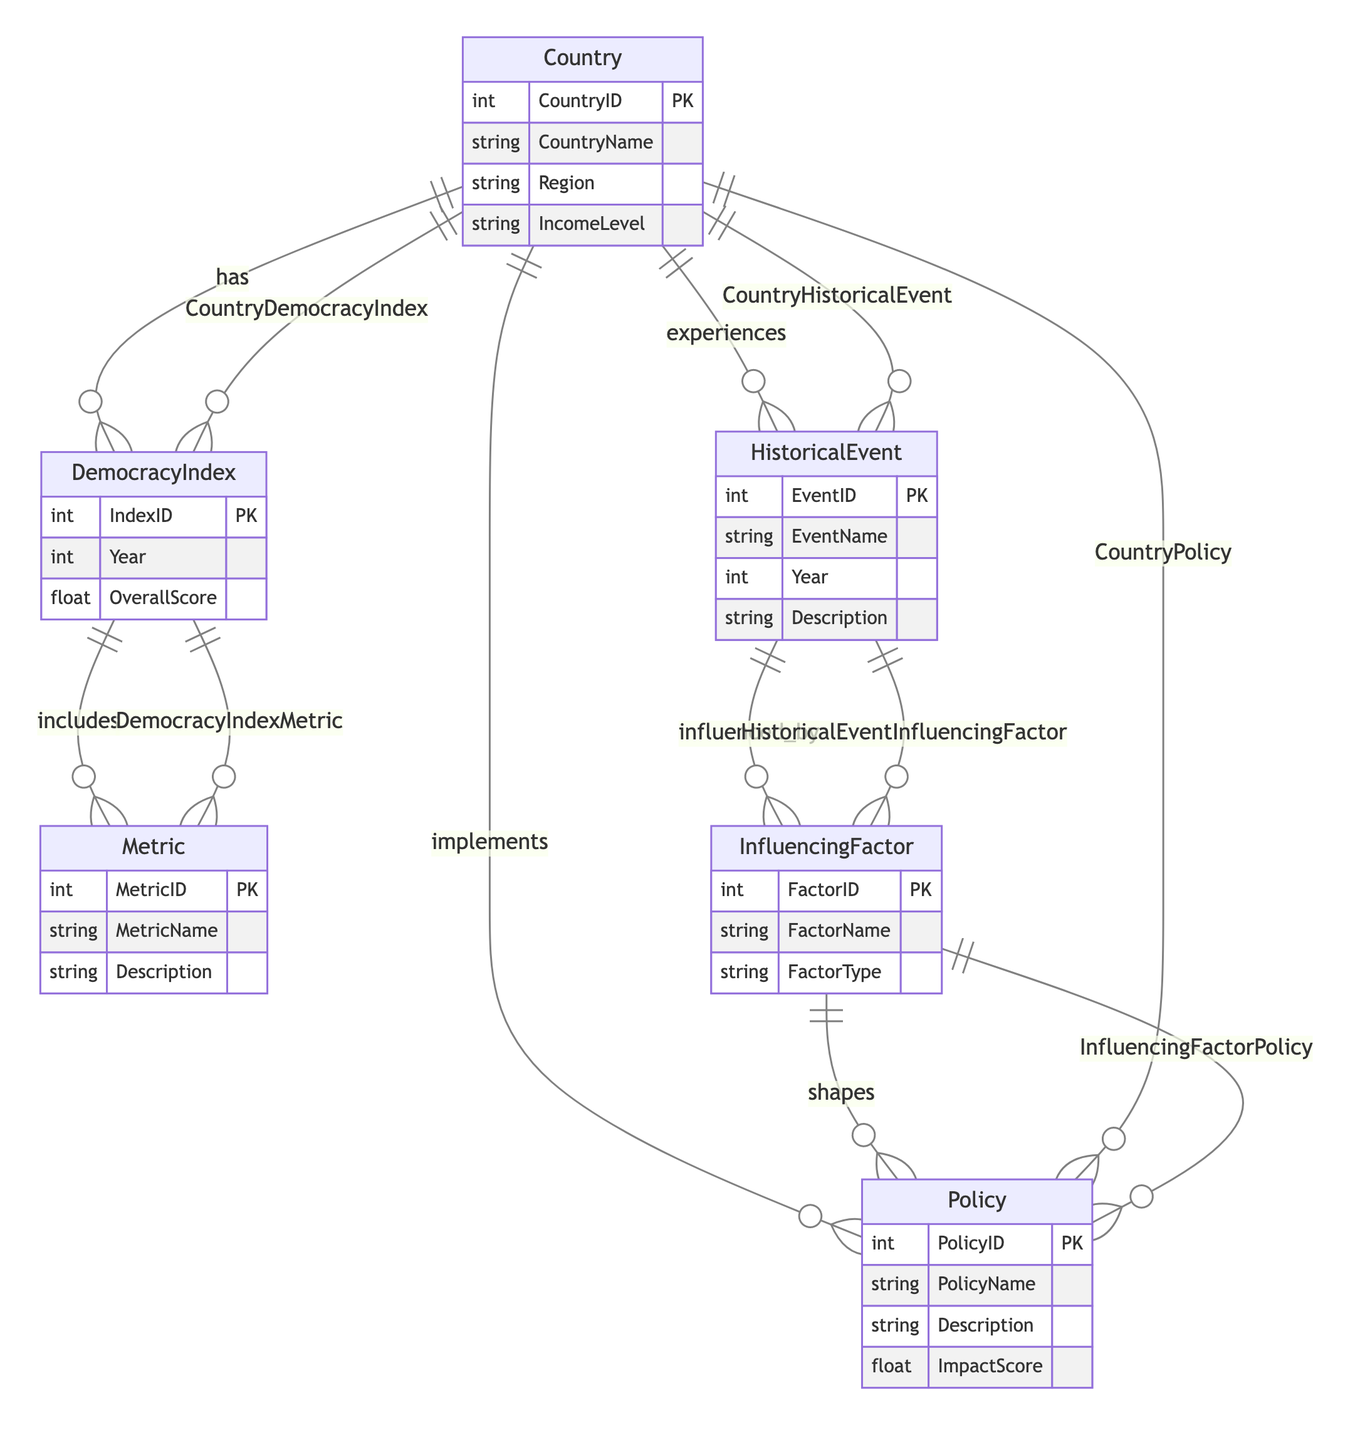What entity represents the overall score of democracy for countries? The entity that includes the overall score of democracy for countries is "DemocracyIndex", which has an attribute called "OverallScore".
Answer: DemocracyIndex How many primary entities are present in the diagram? There are six primary entities in the diagram: Country, DemocracyIndex, Metric, HistoricalEvent, InfluencingFactor, and Policy.
Answer: Six What relationship connects the Country to its historical events? The relationship that connects the Country to its historical events is "CountryHistoricalEvent".
Answer: CountryHistoricalEvent What attribute describes the specific scoring for metrics within the DemocracyIndex? The attribute that describes the specific scoring for metrics within the DemocracyIndex is "MetricScore".
Answer: MetricScore Which entity influences the development of policies? The entity that influences the development of policies is "InfluencingFactor".
Answer: InfluencingFactor Identify a type of policy associated with a country and its adoption date. The relationship that connects a country to its policy along with the adoption date is represented by "CountryPolicy" which includes the attribute "AdoptionDate".
Answer: CountryPolicy What type of relationship exists between HistoricalEvent and InfluencingFactor? The relationship between HistoricalEvent and InfluencingFactor is categorized as "influenced_by", indicating that historical events are influenced by factors.
Answer: influenced_by Which metric might describe civil liberties in the context of the diagram? The diagram includes an entity named "Metric", which can contain various metrics, one of which could describe civil liberties although the specific metric for civil liberties is not detailed.
Answer: Metric In how many ways can a country implement policies based on the diagram? According to the diagram, a country can implement policies through the "CountryPolicy" relationship, which allows connecting to various policies.
Answer: One 